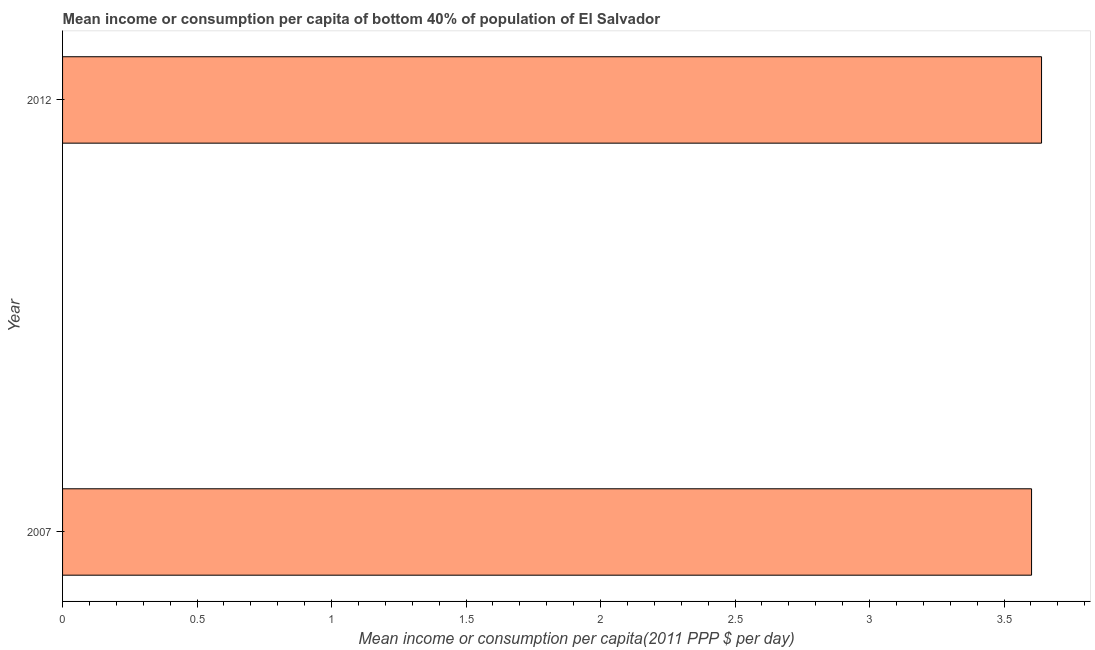Does the graph contain any zero values?
Provide a short and direct response. No. What is the title of the graph?
Make the answer very short. Mean income or consumption per capita of bottom 40% of population of El Salvador. What is the label or title of the X-axis?
Your answer should be compact. Mean income or consumption per capita(2011 PPP $ per day). What is the mean income or consumption in 2007?
Provide a short and direct response. 3.6. Across all years, what is the maximum mean income or consumption?
Ensure brevity in your answer.  3.64. Across all years, what is the minimum mean income or consumption?
Provide a short and direct response. 3.6. In which year was the mean income or consumption maximum?
Offer a terse response. 2012. What is the sum of the mean income or consumption?
Your response must be concise. 7.24. What is the difference between the mean income or consumption in 2007 and 2012?
Ensure brevity in your answer.  -0.04. What is the average mean income or consumption per year?
Give a very brief answer. 3.62. What is the median mean income or consumption?
Provide a short and direct response. 3.62. Is the mean income or consumption in 2007 less than that in 2012?
Offer a terse response. Yes. In how many years, is the mean income or consumption greater than the average mean income or consumption taken over all years?
Keep it short and to the point. 1. How many years are there in the graph?
Provide a short and direct response. 2. Are the values on the major ticks of X-axis written in scientific E-notation?
Make the answer very short. No. What is the Mean income or consumption per capita(2011 PPP $ per day) of 2007?
Provide a succinct answer. 3.6. What is the Mean income or consumption per capita(2011 PPP $ per day) of 2012?
Your response must be concise. 3.64. What is the difference between the Mean income or consumption per capita(2011 PPP $ per day) in 2007 and 2012?
Offer a terse response. -0.04. What is the ratio of the Mean income or consumption per capita(2011 PPP $ per day) in 2007 to that in 2012?
Provide a short and direct response. 0.99. 